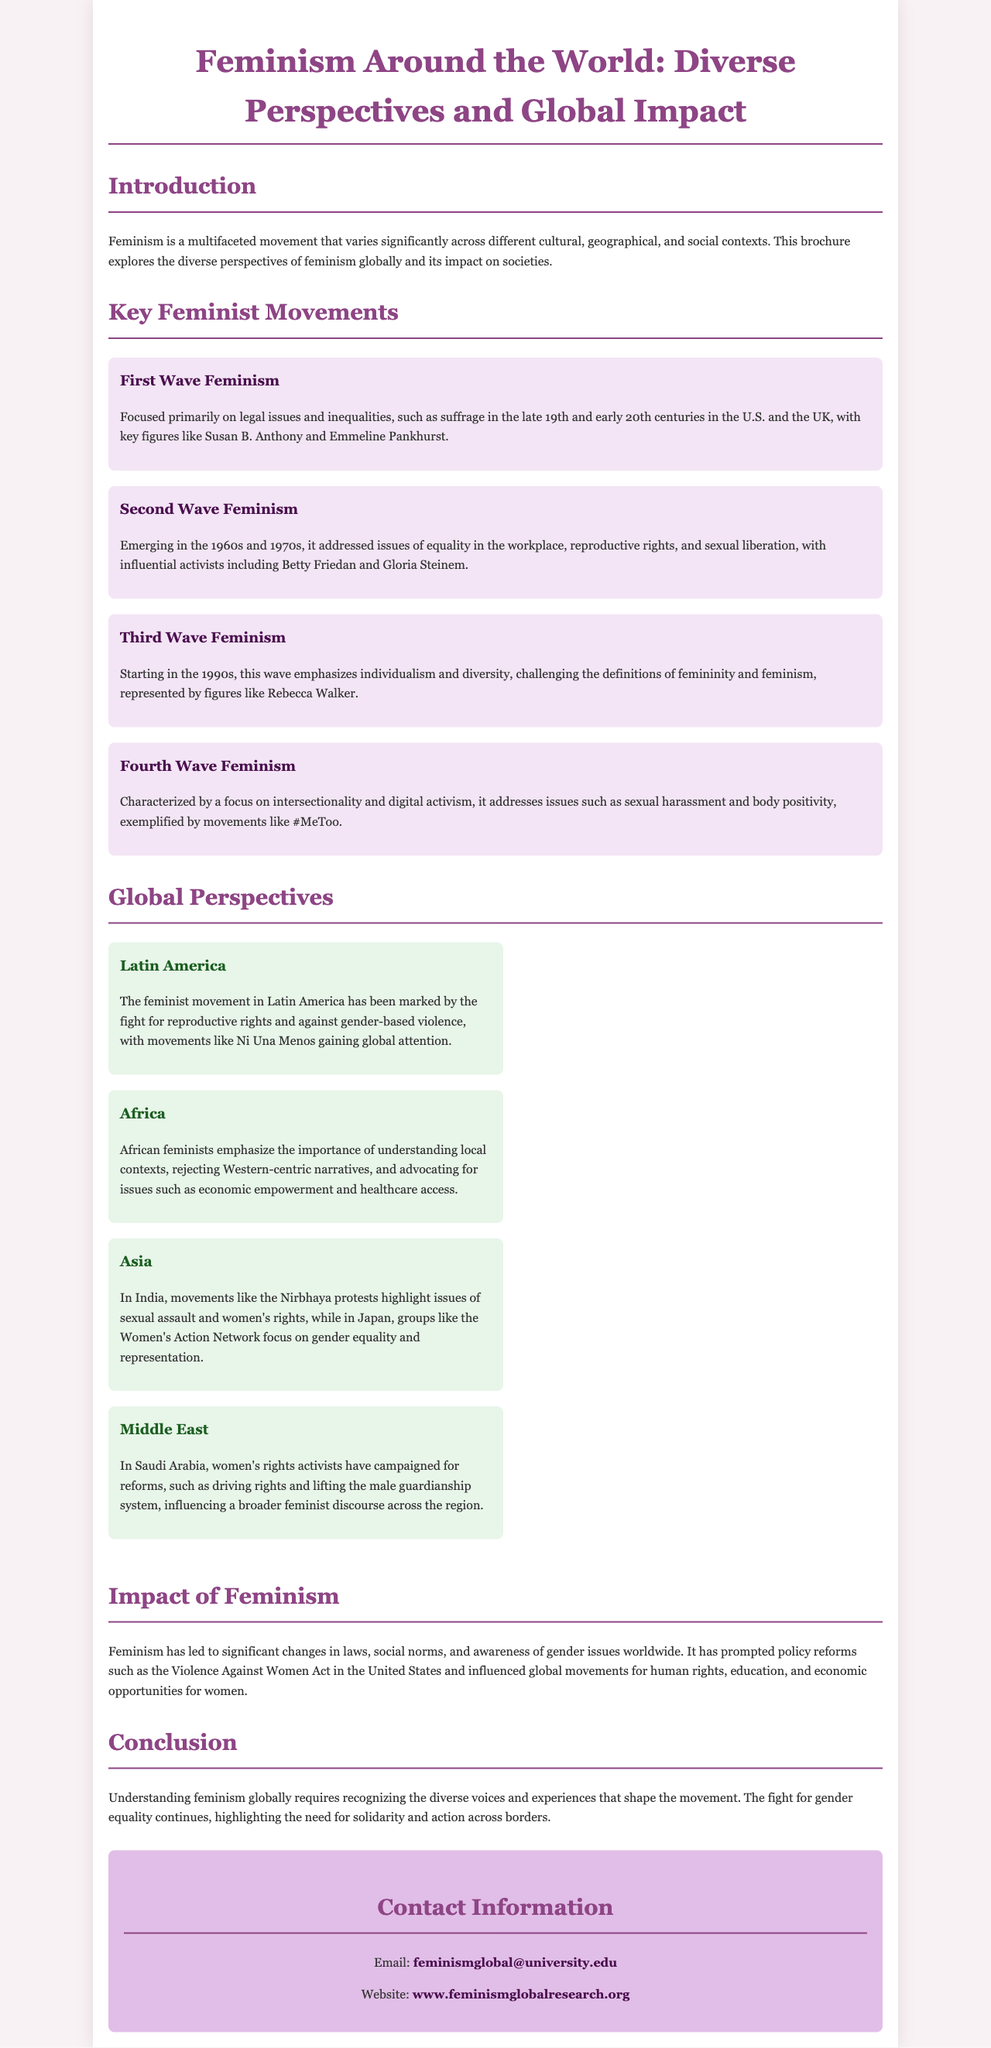What is the title of the brochure? The title is mentioned at the beginning of the document.
Answer: Feminism Around the World: Diverse Perspectives and Global Impact Who were the key figures in First Wave Feminism? The document lists important activists associated with this movement.
Answer: Susan B. Anthony and Emmeline Pankhurst What movement is characterized by a focus on intersectionality and digital activism? The document specifies this particular wave within the feminist movements.
Answer: Fourth Wave Feminism What significant movement has gained global attention in Latin America? The brochure describes a specific feminist movement in this region.
Answer: Ni Una Menos What major theme do African feminists emphasize? The document highlights a specific focus of African feminists.
Answer: Local contexts What act did feminism prompt in the United States? The document references a specific legislation influenced by feminist advocacy.
Answer: Violence Against Women Act Which region's feminists are campaigning for driving rights? The document identifies the activists from a particular geographic area.
Answer: Saudi Arabia What is the email address provided for contact? The document specifies this information in the contact section.
Answer: feminismglobal@university.edu 